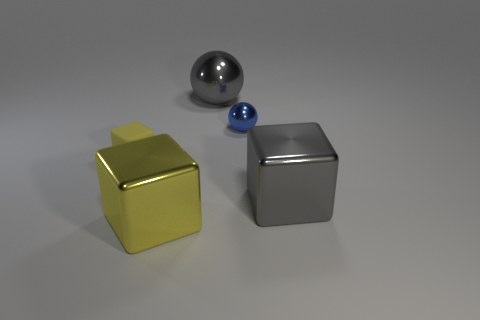Subtract all tiny cubes. How many cubes are left? 2 Add 2 yellow matte things. How many objects exist? 7 Subtract all balls. How many objects are left? 3 Subtract 1 cubes. How many cubes are left? 2 Subtract all gray spheres. Subtract all green blocks. How many spheres are left? 1 Subtract all green blocks. How many gray balls are left? 1 Subtract all tiny yellow rubber things. Subtract all large purple rubber balls. How many objects are left? 4 Add 1 big metallic cubes. How many big metallic cubes are left? 3 Add 3 small matte balls. How many small matte balls exist? 3 Subtract all gray blocks. How many blocks are left? 2 